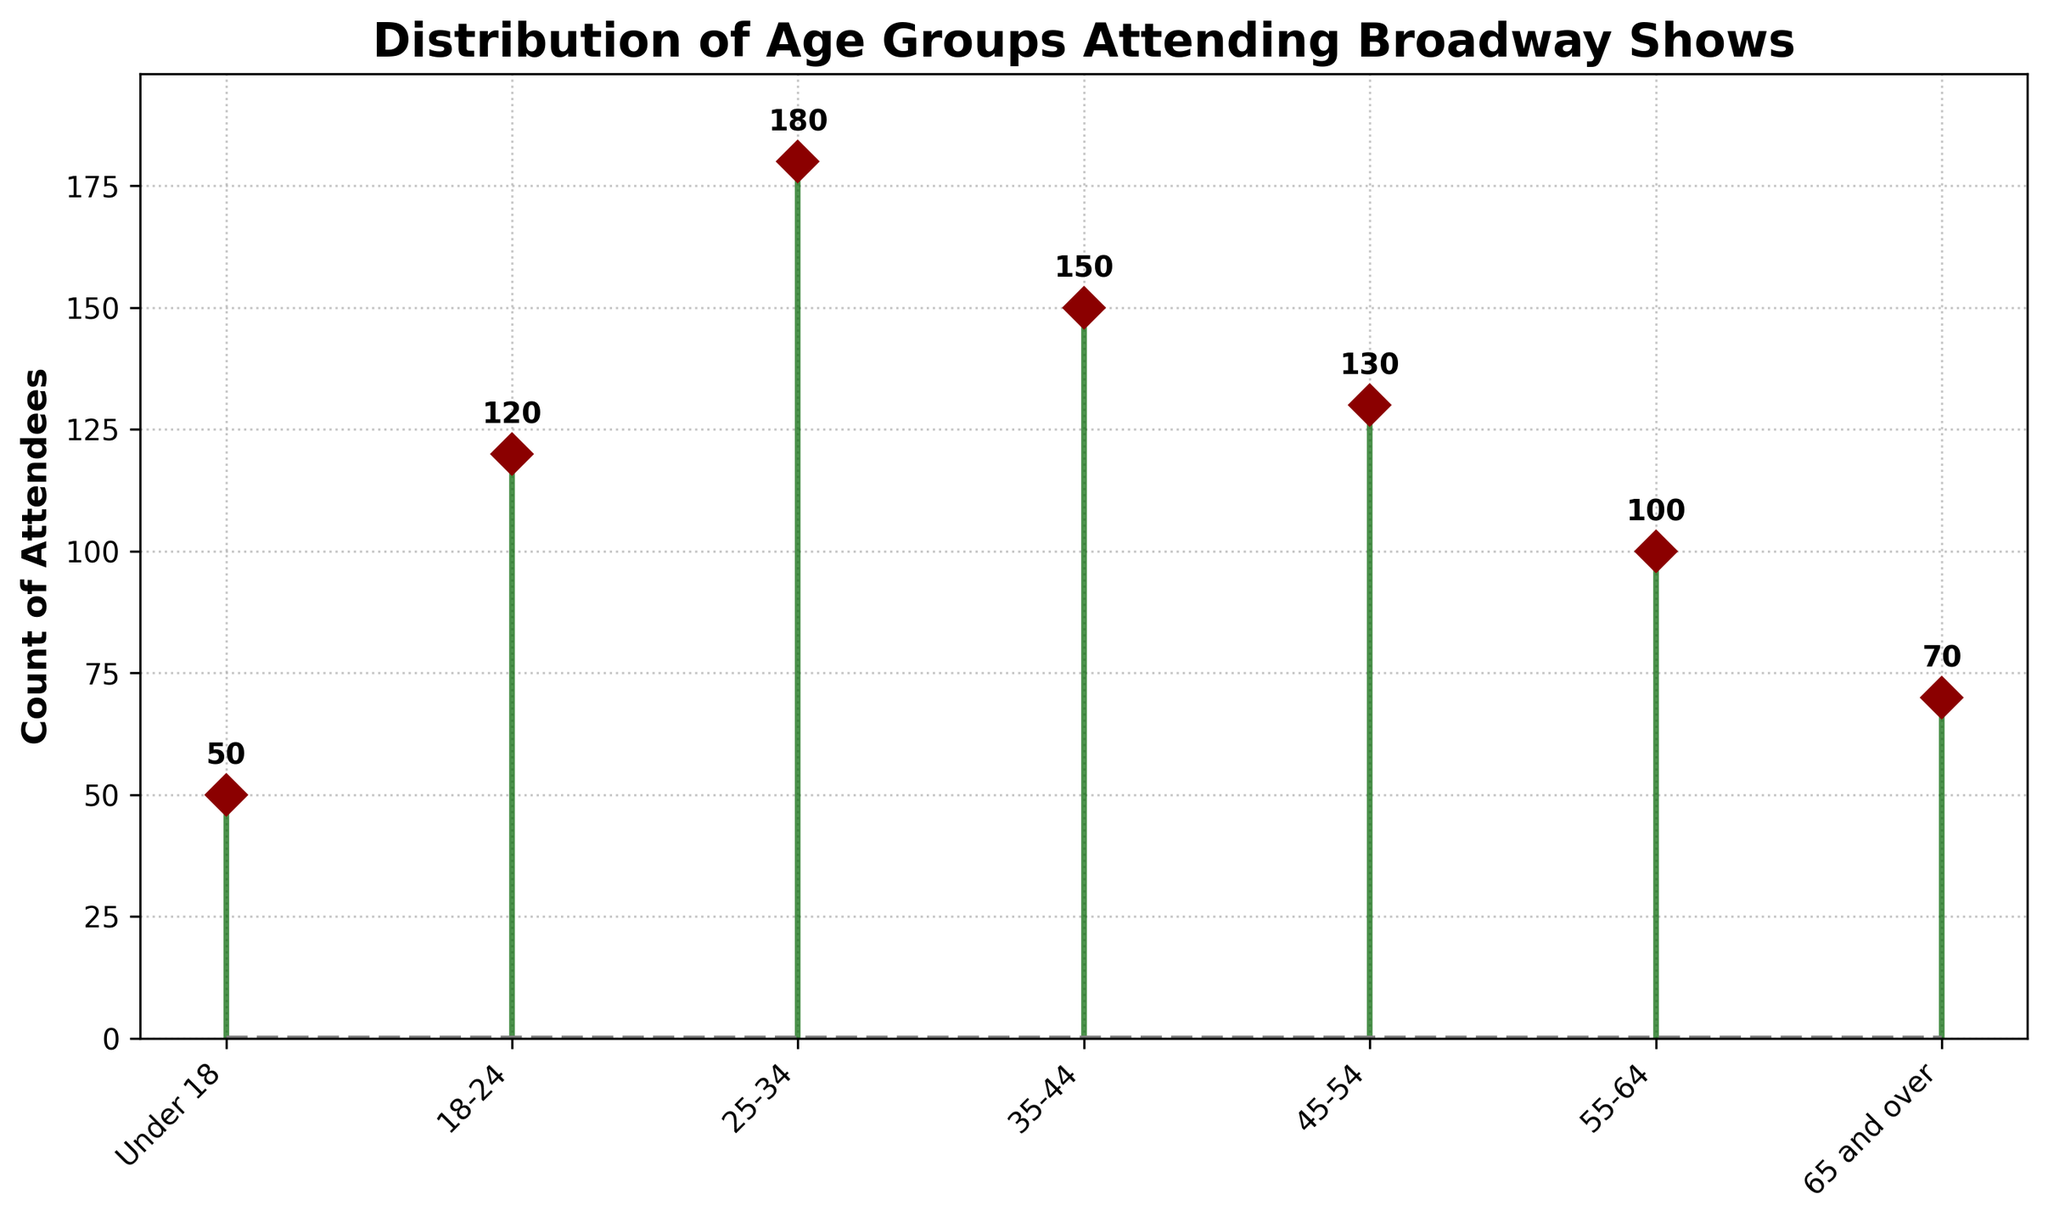Which age group had the highest attendance? By looking at the stem plot, the highest y-value correlates with the age group 25-34, which has a value of 180.
Answer: 25-34 How many more attendees were there in the 35-44 age group compared to the 55-64 age group? The attendance for 35-44 is 150, and for 55-64 it is 100. Subtracting these values, 150 - 100 gives 50 more attendees.
Answer: 50 What is the total number of attendees across all age groups? Adding up the counts for all age groups: 50 (Under 18) + 120 (18-24) + 180 (25-34) + 150 (35-44) + 130 (45-54) + 100 (55-64) + 70 (65 and over) equals 800.
Answer: 800 What is the range of attendees across the age groups? The range is found by subtracting the smallest value from the largest value: 180 (highest) - 50 (lowest) equals 130.
Answer: 130 Which age group has the second-lowest attendance? The lowest attendance is Under 18 with 50 attendees. The next lowest is 65 and over with 70 attendees.
Answer: 65 and over Are there more attendees in the 18-24 and 25-34 age groups combined than the total for the 45-54, 55-64, and 65 and over age groups? Adding 18-24 and 25-34: 120 + 180 equals 300. Adding 45-54, 55-64, and 65 and over: 130 + 100 + 70 equals 300. Both sums are equal.
Answer: No What is the average number of attendees per age group? Summing all attendees: 50 + 120 + 180 + 150 + 130 + 100 + 70 equals 800. Dividing by the number of age groups, 800 / 7 equals approximately 114.3.
Answer: 114.3 Which age group showed a more significant decrease in attendance compared to its immediate predecessor: 45-54 to 55-64, or 55-64 to 65 and over? The decrease from 45-54 (130) to 55-64 (100) is 130 - 100 = 30. The decrease from 55-64 (100) to 65 and over (70) is 100 - 70 = 30. Both decreases are identical.
Answer: Neither, both are 30 